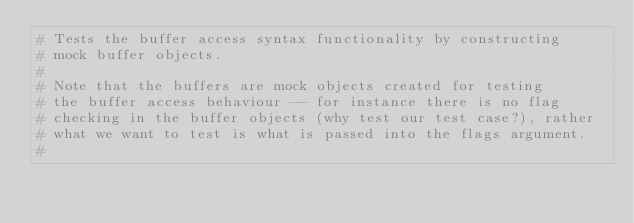Convert code to text. <code><loc_0><loc_0><loc_500><loc_500><_Cython_># Tests the buffer access syntax functionality by constructing
# mock buffer objects.
#
# Note that the buffers are mock objects created for testing
# the buffer access behaviour -- for instance there is no flag
# checking in the buffer objects (why test our test case?), rather
# what we want to test is what is passed into the flags argument.
#
</code> 